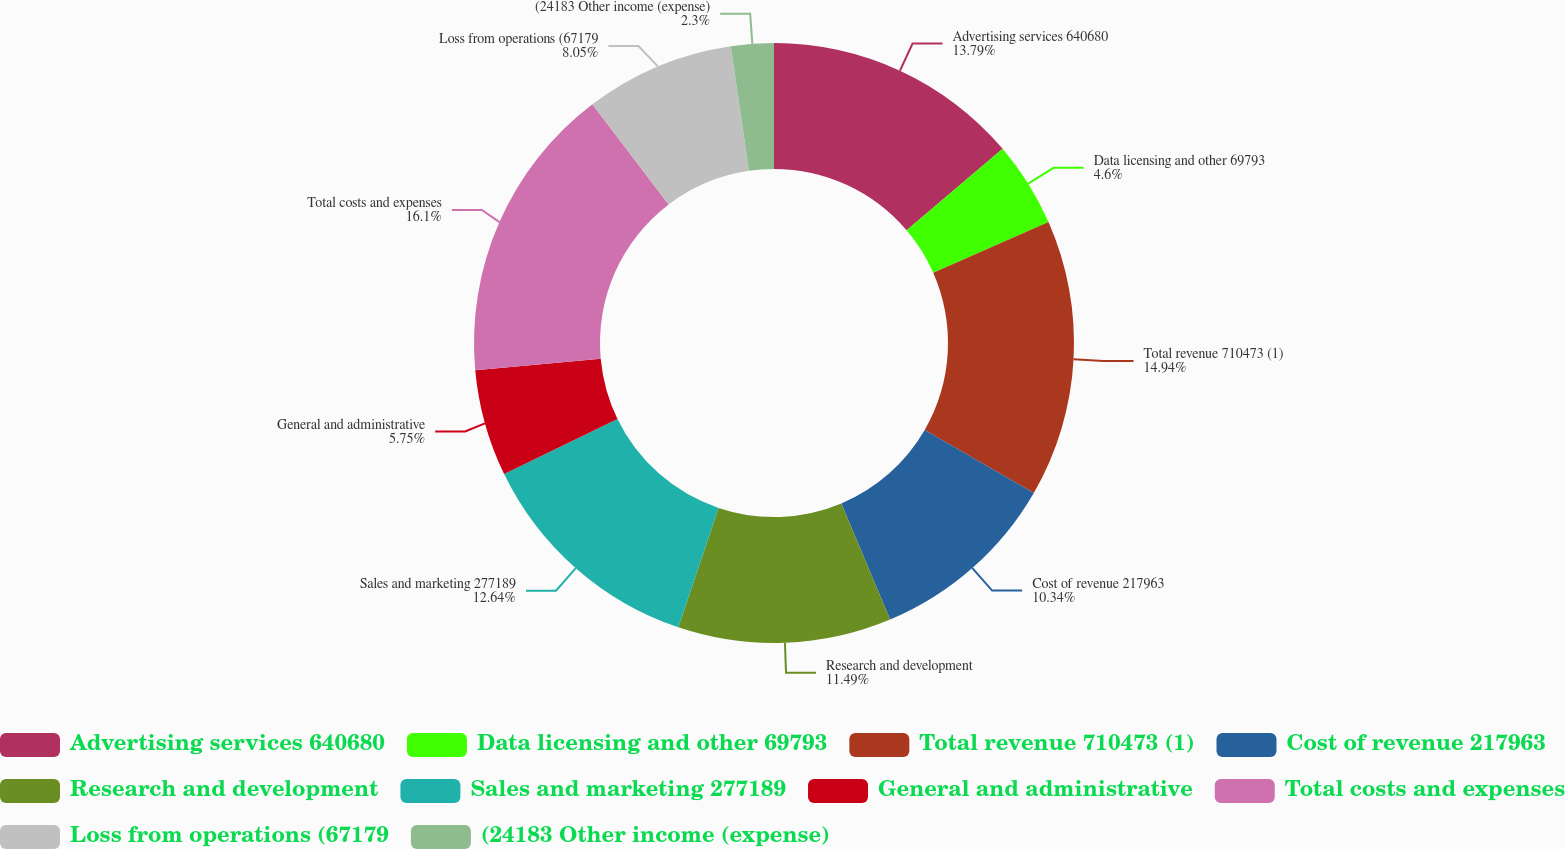Convert chart. <chart><loc_0><loc_0><loc_500><loc_500><pie_chart><fcel>Advertising services 640680<fcel>Data licensing and other 69793<fcel>Total revenue 710473 (1)<fcel>Cost of revenue 217963<fcel>Research and development<fcel>Sales and marketing 277189<fcel>General and administrative<fcel>Total costs and expenses<fcel>Loss from operations (67179<fcel>(24183 Other income (expense)<nl><fcel>13.79%<fcel>4.6%<fcel>14.94%<fcel>10.34%<fcel>11.49%<fcel>12.64%<fcel>5.75%<fcel>16.09%<fcel>8.05%<fcel>2.3%<nl></chart> 